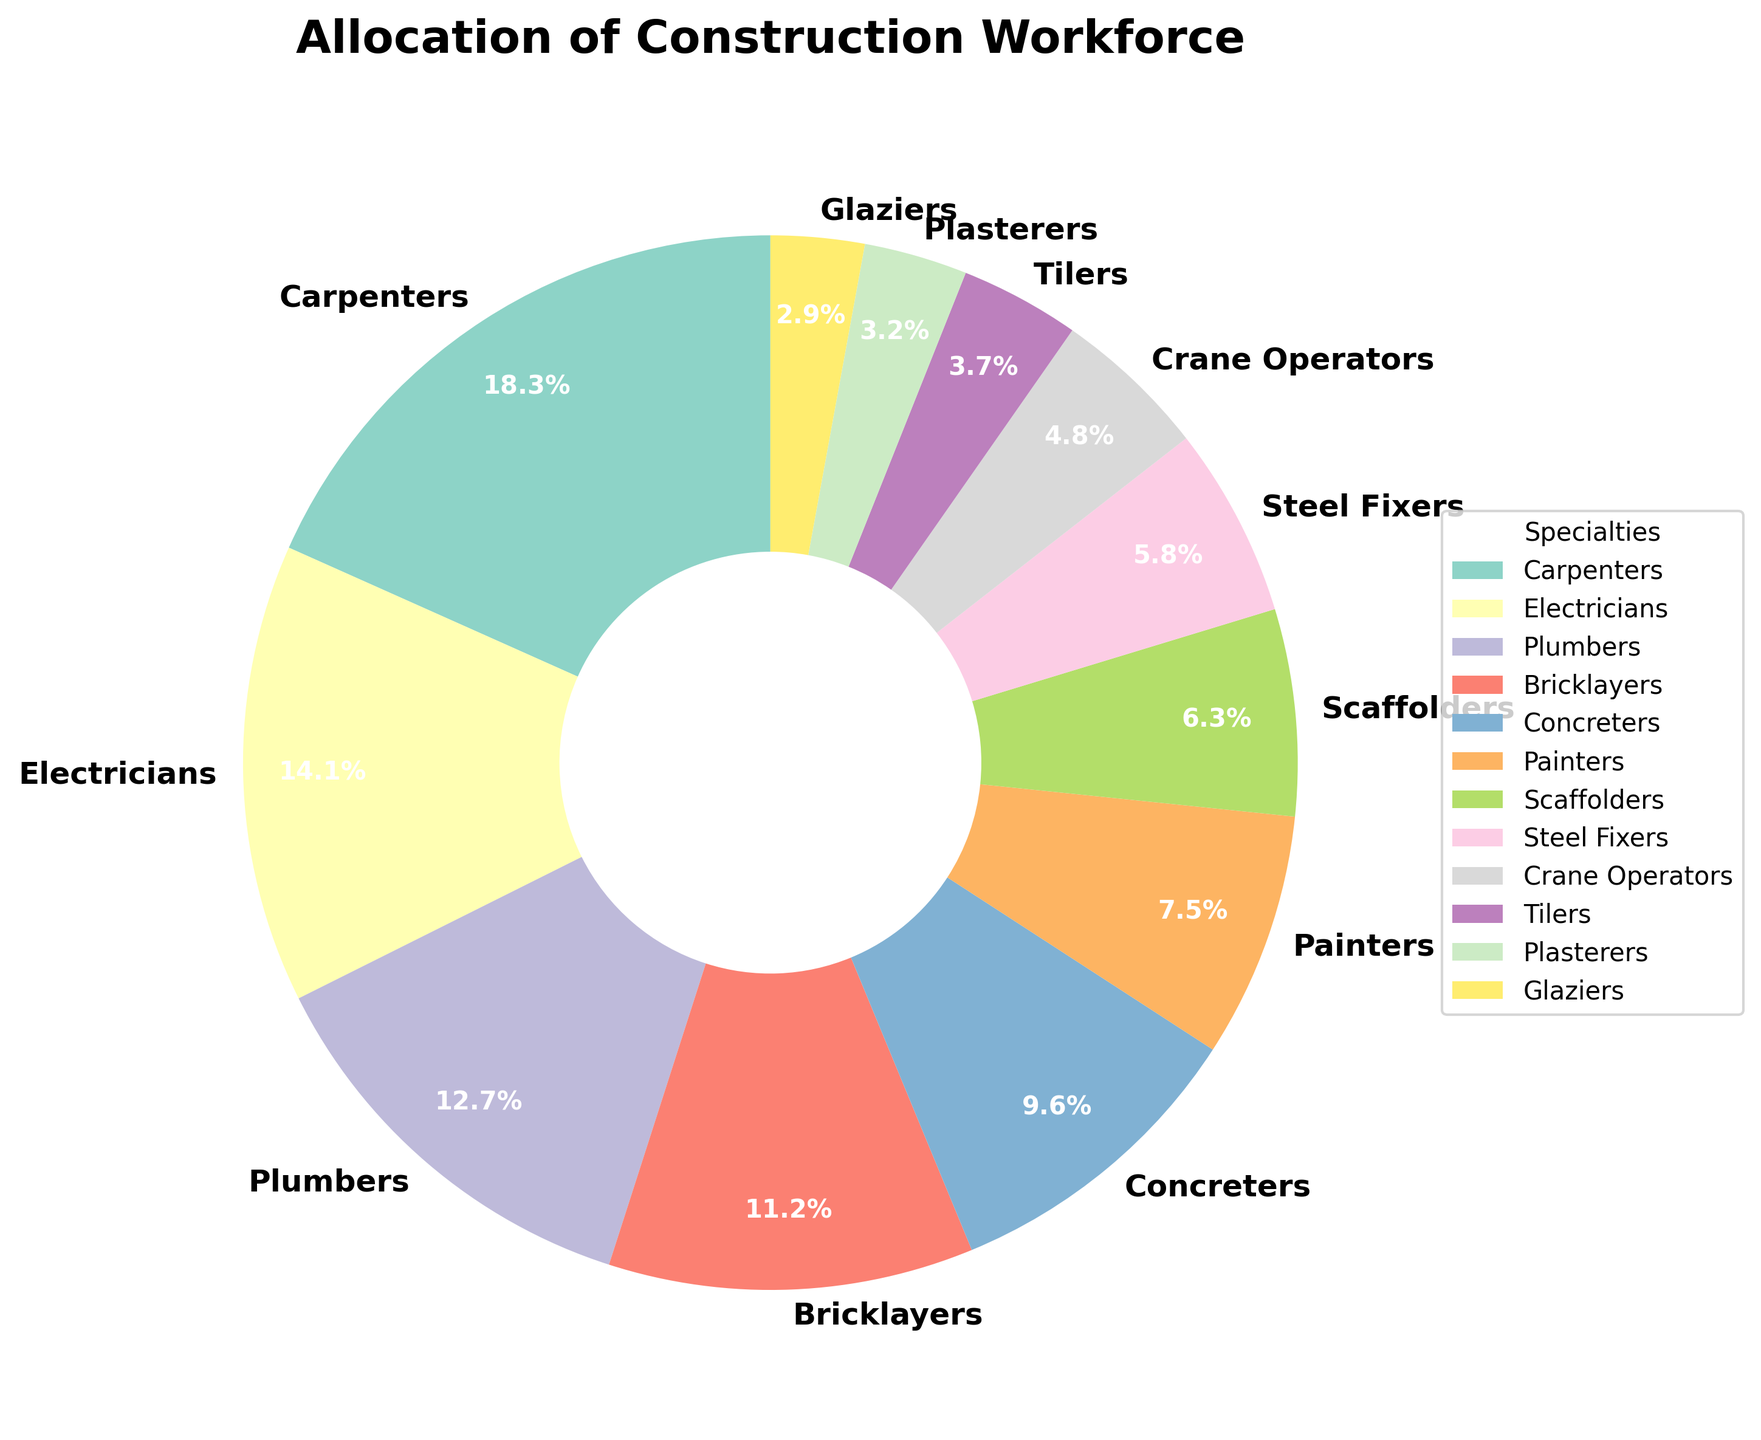What percentage of the workforce is allocated to Carpenters and Electricians combined? To find the percentage allocated to Carpenters and Electricians combined, sum their individual percentages: 18.5% (Carpenters) + 14.2% (Electricians) = 32.7%.
Answer: 32.7% Which specialty has the smallest allocation of the workforce? By examining the pie chart, the specialty with the smallest segment is Glaziers, with 2.9% of the workforce.
Answer: Glaziers Among Bricklayers, Concreters, and Painters, which specialty has the highest workforce allocation? By comparing the percentages of Bricklayers (11.3%), Concreters (9.7%), and Painters (7.6%) from the chart, Bricklayers have the highest workforce allocation.
Answer: Bricklayers What is the difference in workforce allocation between Plumbers and Crane Operators? To find the difference in allocation between Plumbers and Crane Operators, subtract the percentage of Crane Operators from Plumbers: 12.8% (Plumbers) - 4.8% (Crane Operators) = 8.0%.
Answer: 8.0% Are there more workers allocated to Steel Fixers or Scaffolders, and by how much? Steel Fixers have 5.9% and Scaffolders have 6.4% of the workforce. Scaffolders have a greater allocation. The difference is 6.4% - 5.9% = 0.5%.
Answer: Scaffolders by 0.5% Which three specialties together make up the largest portion of the workforce? By adding the top three percentages: 18.5% (Carpenters) + 14.2% (Electricians) + 12.8% (Plumbers) = 45.5%, they make up the largest portion.
Answer: Carpenters, Electricians, Plumbers How many specialties have an allocation of less than 5% of the workforce? By examining the chart, the specialties with less than 5% allocation are Crane Operators (4.8%), Tilers (3.7%), Plasterers (3.2%), and Glaziers (2.9%), totaling 4 specialties.
Answer: 4 What is the average percentage allocation across all specialties? Sum all the percentages and divide by the number of specialties. The sum is 18.5 + 14.2 + 12.8 + 11.3 + 9.7 + 7.6 + 6.4 + 5.9 + 4.8 + 3.7 + 3.2 + 2.9 = 100.0. There are 12 specialties, so 100.0 / 12 = 8.33.
Answer: 8.33% Which specialty is represented by the third largest segment in the pie chart? The third largest segment by percentage is Plumbers at 12.8%, following Carpenters (18.5%) and Electricians (14.2%).
Answer: Plumbers 